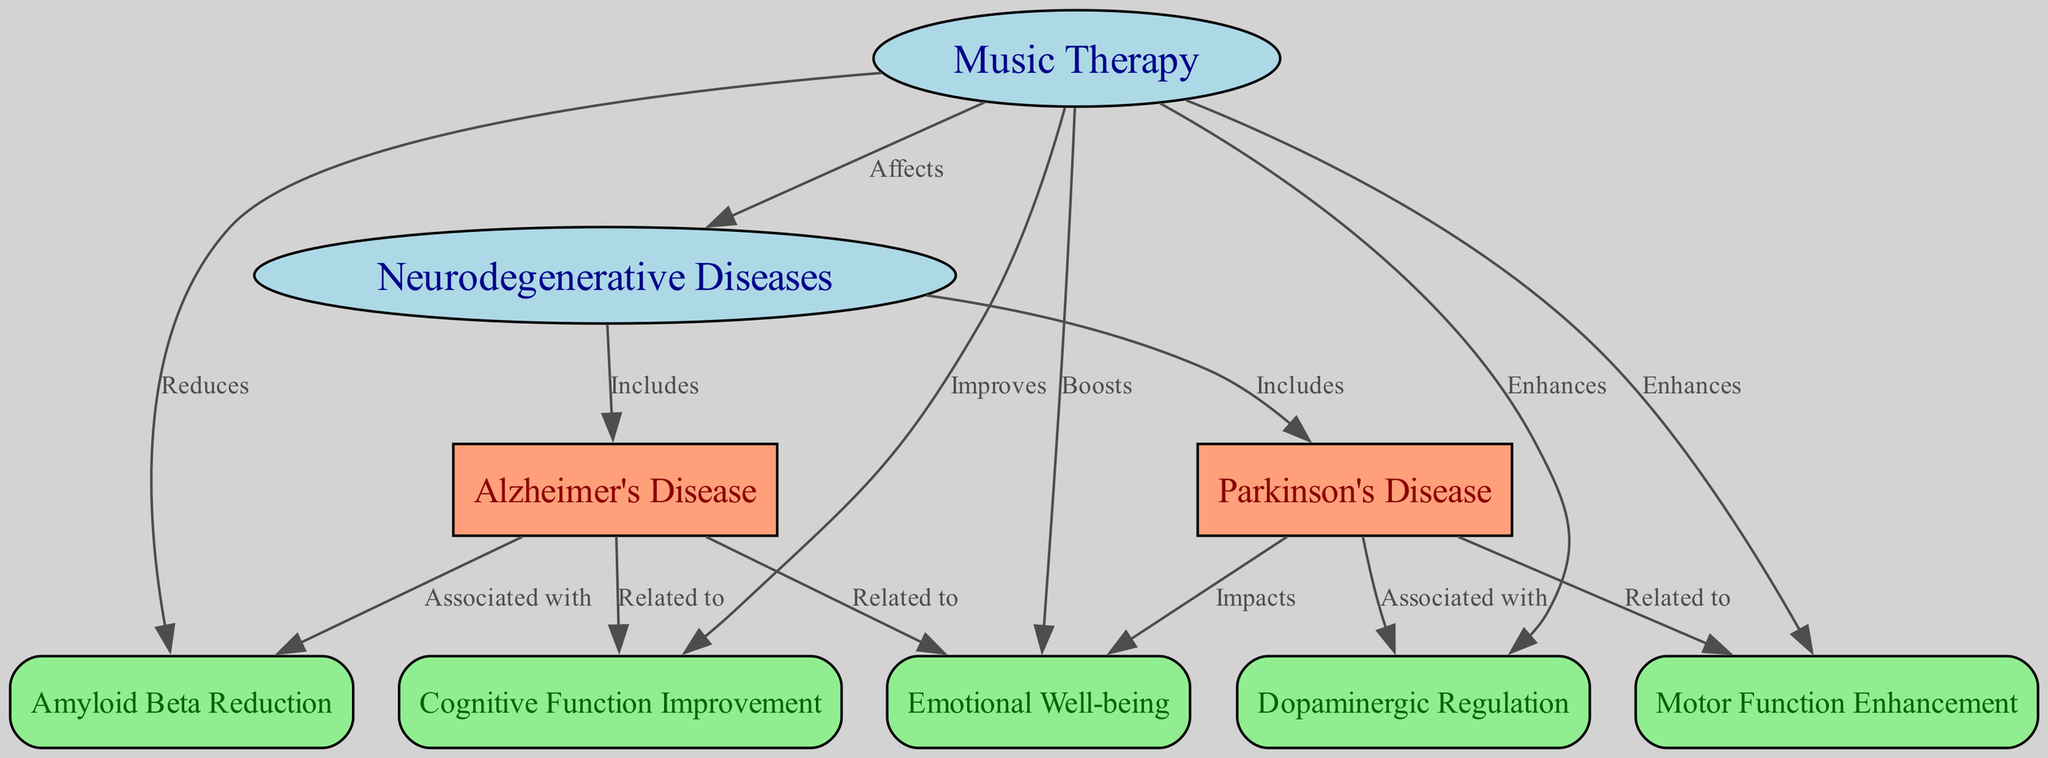What is the main subject of the diagram? The main subject is identified by the first node labeled "Music Therapy", which serves as the central concept linking it to neurodegenerative diseases.
Answer: Music Therapy How many nodes are present in the diagram? Counting the number of unique entries in the nodes section, there are nine distinct nodes indicated in the diagram.
Answer: 9 What type of relationship exists between Music Therapy and Neurodegenerative Diseases? The directed edge from "Music Therapy" to "Neurodegenerative Diseases" is labeled "Affects", indicating a direct impact of music therapy on these diseases.
Answer: Affects Which two diseases are included under Neurodegenerative Diseases? The diseases linked to the node "Neurodegenerative Diseases" include "Alzheimer's Disease" and "Parkinson's Disease", as indicated by the edges labeled "Includes".
Answer: Alzheimer's Disease and Parkinson's Disease What effect does Music Therapy have on Cognitive Function? The edge from "Music Therapy" to "Cognitive Function Improvement" is marked as "Improves", signifying that music therapy has a positive effect on cognitive function.
Answer: Improves How does Music Therapy influence Emotional Well-being in patients? The labeled edge from "Music Therapy" to "Emotional Well-being" shows that it "Boosts" emotional health, indicating an enhancement in patients' emotional states.
Answer: Boosts What is the relationship between Alzheimer's Disease and Amyloid Beta Reduction? The diagram shows that "Alzheimer's Disease" is "Associated with" "Amyloid Beta Reduction", suggesting a connection where the presence of Alzheimer's disease correlates with amyloid beta levels.
Answer: Associated with How does Music Therapy relate to Motor Function Enhancement in Parkinson's Disease? The edge connecting "Music Therapy" to "Motor Function Enhancement" is labeled "Enhances", indicating that music therapy aids in improving motor function specifically related to Parkinson's Disease.
Answer: Enhances What are the two impacts of Music Therapy on Parkinson's Disease according to the diagram? The diagram indicates that "Music Therapy" is linked to "Dopaminergic Regulation" and "Motor Function Enhancement", showcasing its dual influence on this condition.
Answer: Dopaminergic Regulation, Motor Function Enhancement 